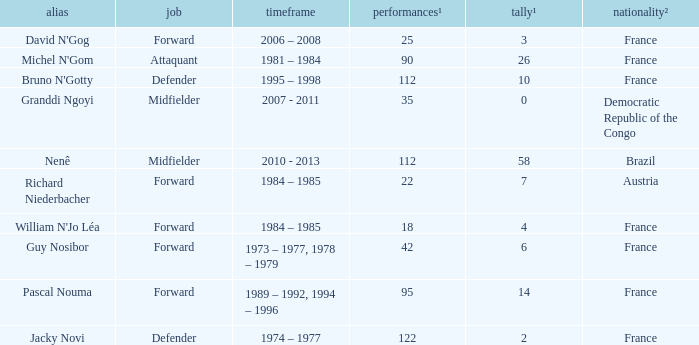List the player that scored 4 times. William N'Jo Léa. 